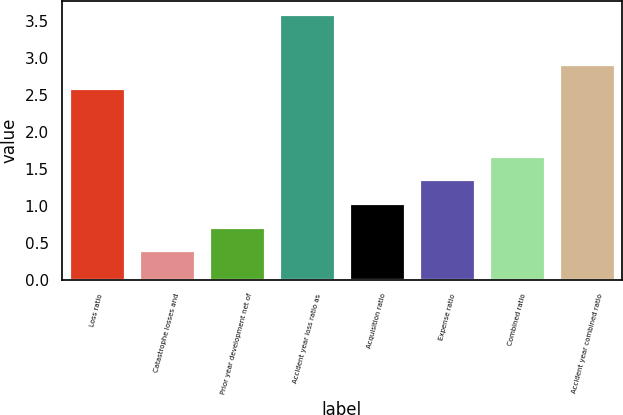<chart> <loc_0><loc_0><loc_500><loc_500><bar_chart><fcel>Loss ratio<fcel>Catastrophe losses and<fcel>Prior year development net of<fcel>Accident year loss ratio as<fcel>Acquisition ratio<fcel>Expense ratio<fcel>Combined ratio<fcel>Accident year combined ratio<nl><fcel>2.6<fcel>0.4<fcel>0.72<fcel>3.6<fcel>1.04<fcel>1.36<fcel>1.68<fcel>2.92<nl></chart> 